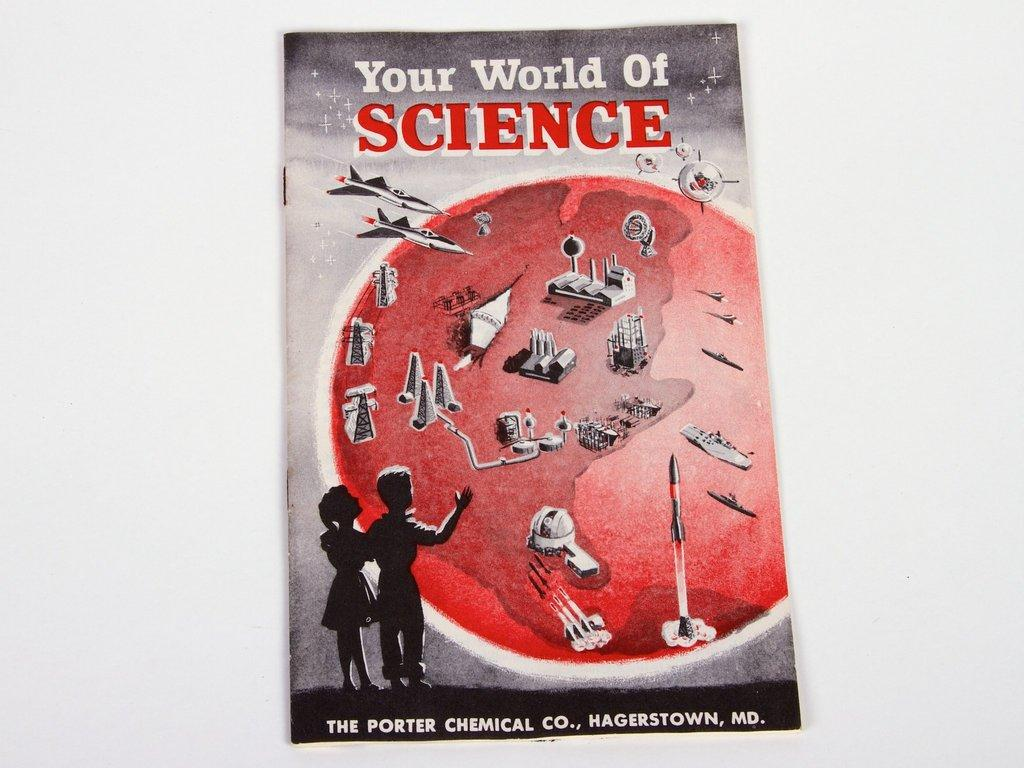<image>
Present a compact description of the photo's key features. Your World of Science is printed by the Porter Chemical Co. 